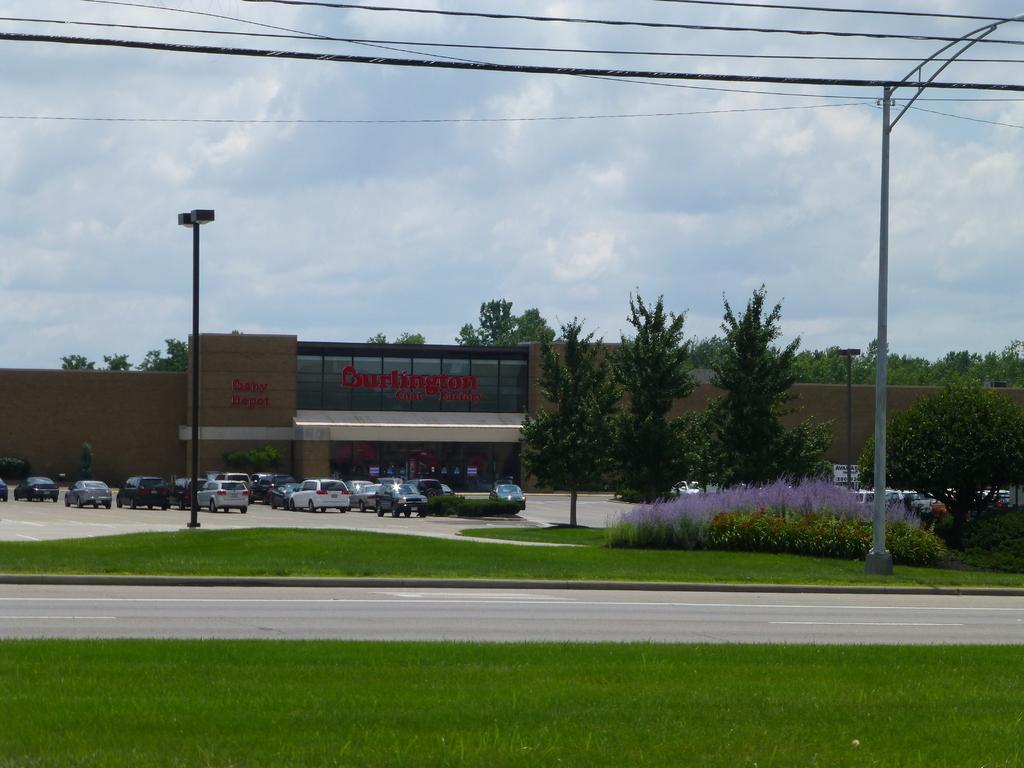Describe this image in one or two sentences. In this picture we can see some grass on both sides of the road. We can see a few plants and a tree on the right side. There are a few poles and some wires are visible on top. There are a few vehicles visible on the path. We can see some text on a building. There are a few trees visible in the background. Sky is blue in color and cloudy. 